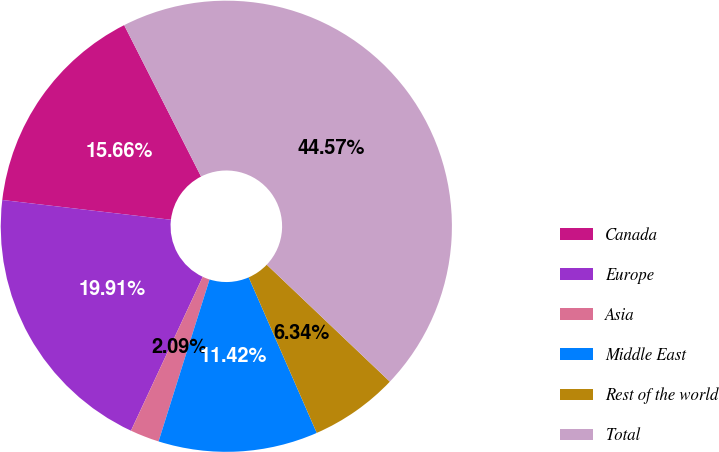Convert chart to OTSL. <chart><loc_0><loc_0><loc_500><loc_500><pie_chart><fcel>Canada<fcel>Europe<fcel>Asia<fcel>Middle East<fcel>Rest of the world<fcel>Total<nl><fcel>15.66%<fcel>19.91%<fcel>2.09%<fcel>11.42%<fcel>6.34%<fcel>44.57%<nl></chart> 